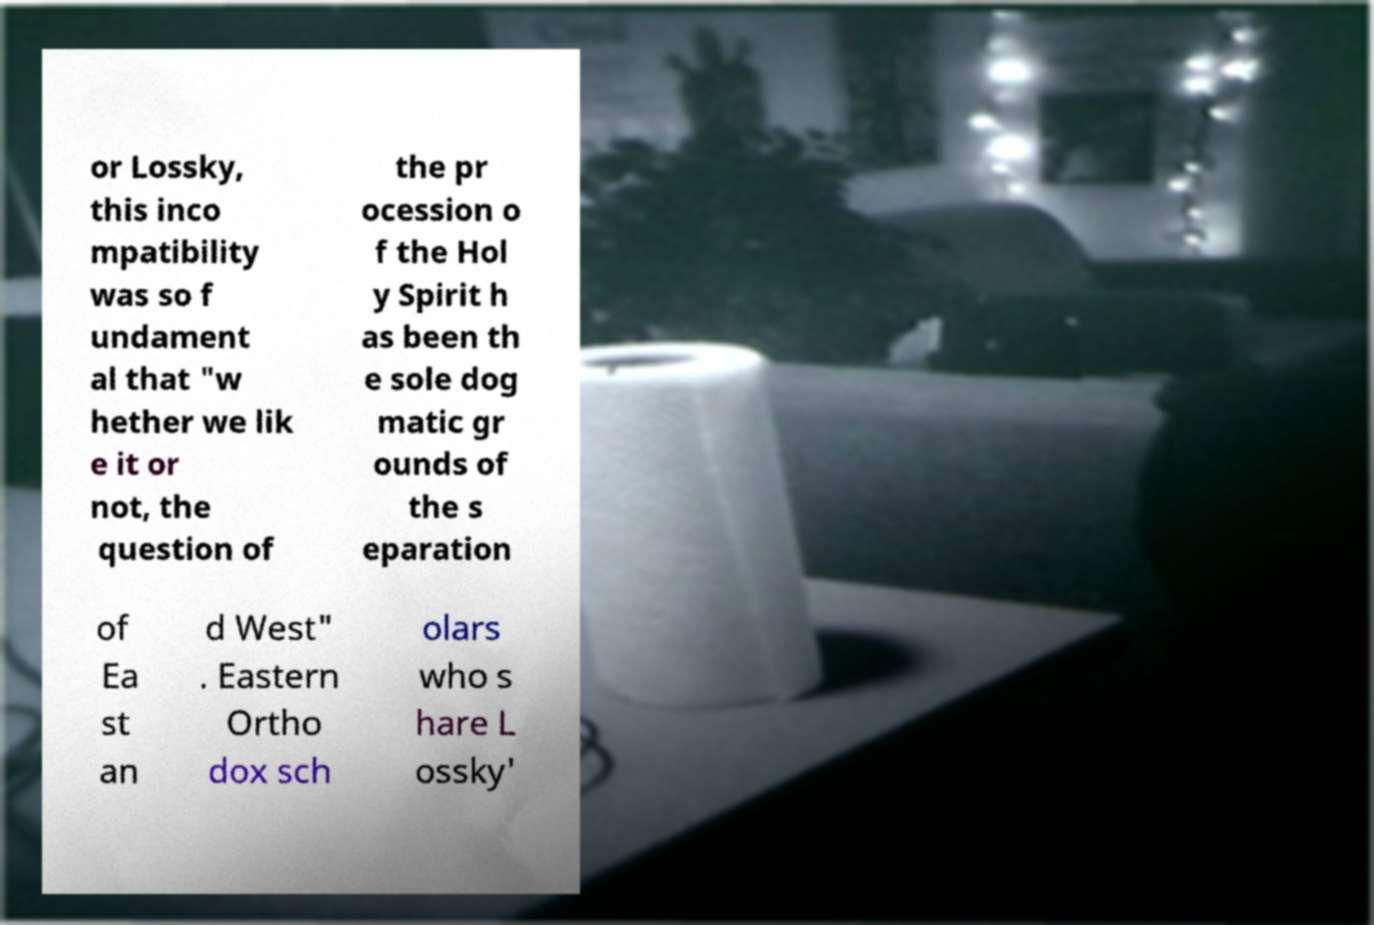There's text embedded in this image that I need extracted. Can you transcribe it verbatim? or Lossky, this inco mpatibility was so f undament al that "w hether we lik e it or not, the question of the pr ocession o f the Hol y Spirit h as been th e sole dog matic gr ounds of the s eparation of Ea st an d West" . Eastern Ortho dox sch olars who s hare L ossky' 